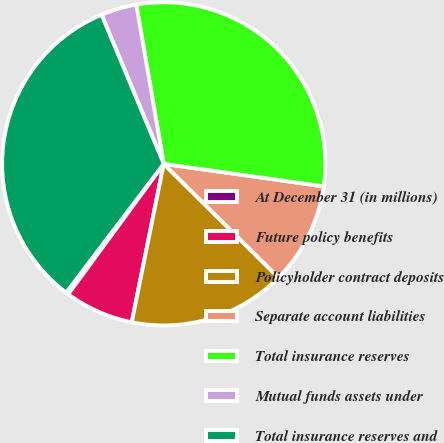Convert chart. <chart><loc_0><loc_0><loc_500><loc_500><pie_chart><fcel>At December 31 (in millions)<fcel>Future policy benefits<fcel>Policyholder contract deposits<fcel>Separate account liabilities<fcel>Total insurance reserves<fcel>Mutual funds assets under<fcel>Total insurance reserves and<nl><fcel>0.26%<fcel>6.89%<fcel>15.75%<fcel>10.2%<fcel>29.94%<fcel>3.57%<fcel>33.39%<nl></chart> 